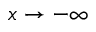Convert formula to latex. <formula><loc_0><loc_0><loc_500><loc_500>x \rightarrow - \infty</formula> 